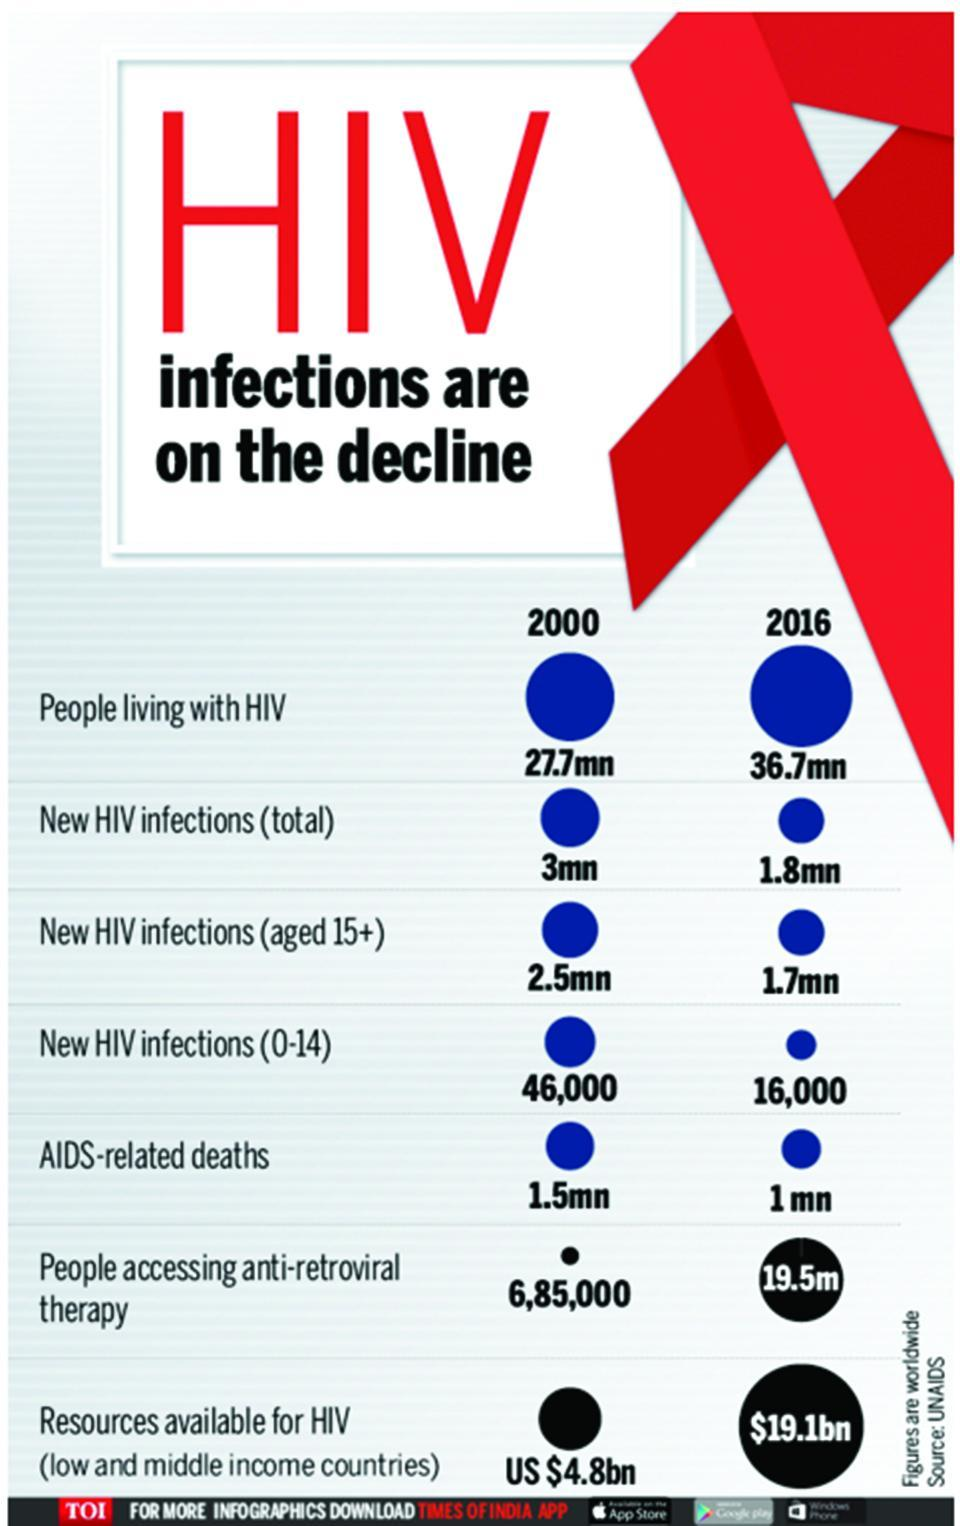How many people were killed due to AIDS in the world in 2000?
Answer the question with a short phrase. 1.5mn What is the number of people living with HIV on antiretroviral therapy globally in 2016? 19.5m How many people in the world have HIV in 2016? 36.7mn What is the number of newly infected HIV cases in the age group of 0-14 years globally in 2016? 16,000 What is the total new HIV infections in the world in 2000? 3mn How many newly infected HIV cases aged above 15 years were reported globally in 2016? 1.7mn 